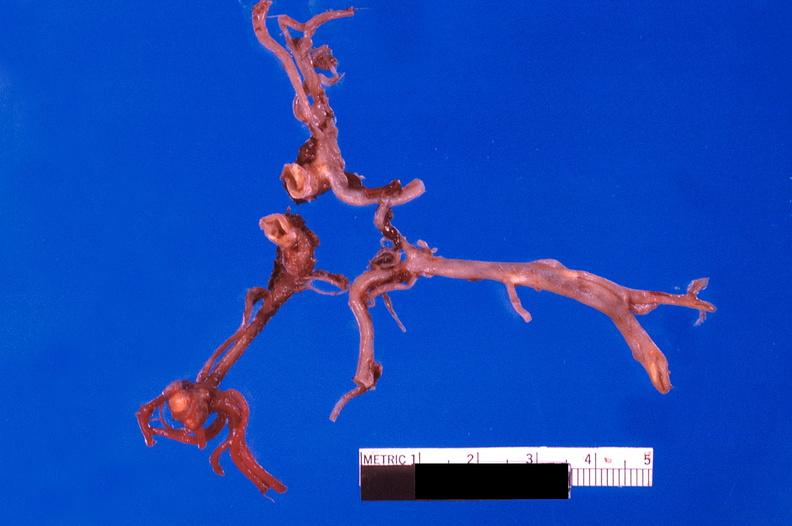s vasculature present?
Answer the question using a single word or phrase. Yes 